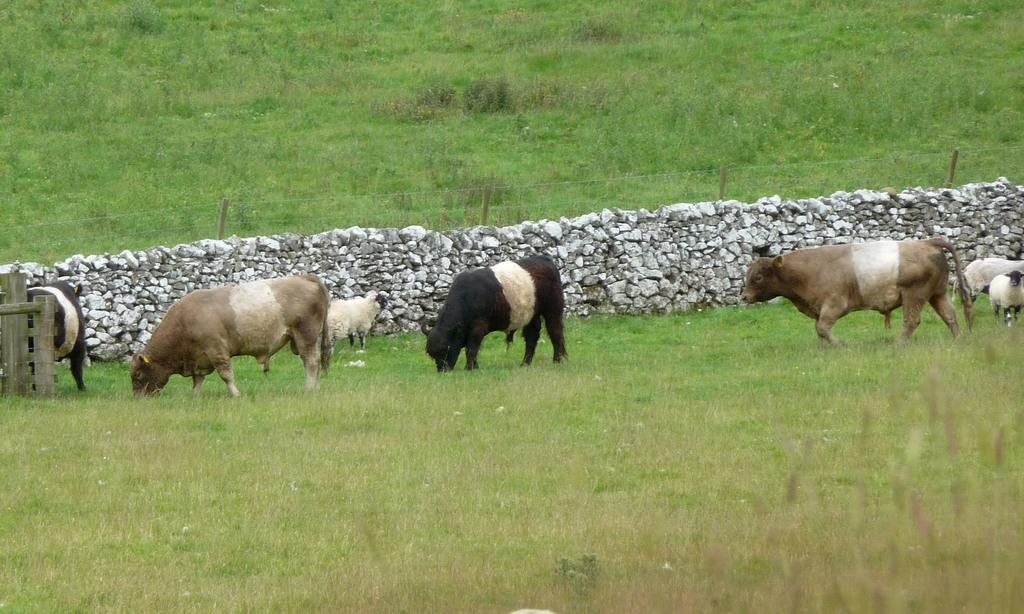What type of surface is visible in the image? There is a grass surface in the image. What are the cows doing on the grass surface? The cows are grazing on the grass. What can be seen on the wall in the image? The wall has stones in the image. What is visible behind the wall? There is another grass surface visible behind the wall. What type of flowers can be seen growing on the top of the wall? There are no flowers visible on the wall in the image. 